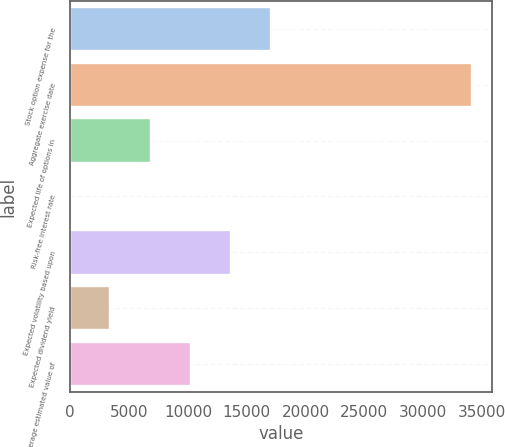Convert chart. <chart><loc_0><loc_0><loc_500><loc_500><bar_chart><fcel>Stock option expense for the<fcel>Aggregate exercise date<fcel>Expected life of options in<fcel>Risk-free interest rate<fcel>Expected volatility based upon<fcel>Expected dividend yield<fcel>Average estimated value of<nl><fcel>17086.7<fcel>34171<fcel>6836.04<fcel>2.3<fcel>13669.8<fcel>3419.17<fcel>10252.9<nl></chart> 